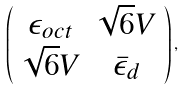<formula> <loc_0><loc_0><loc_500><loc_500>\left ( \begin{array} { c c } \epsilon _ { o c t } & \sqrt { 6 } V \\ \sqrt { 6 } V & \bar { \epsilon } _ { d } \end{array} \right ) ,</formula> 